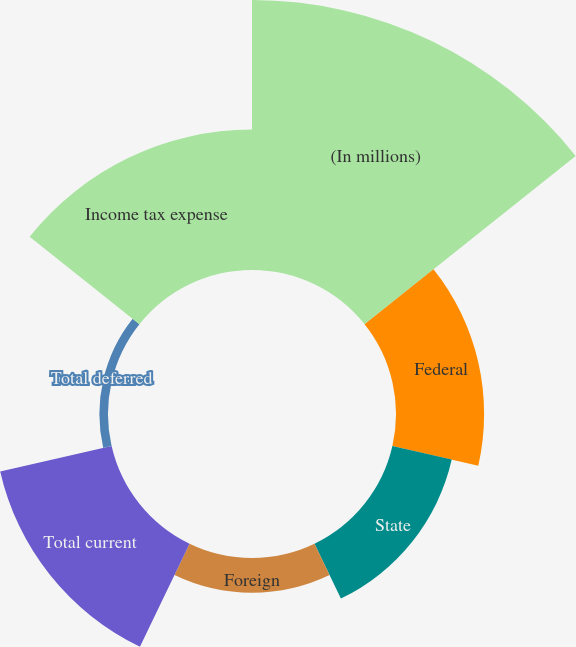<chart> <loc_0><loc_0><loc_500><loc_500><pie_chart><fcel>(In millions)<fcel>Federal<fcel>State<fcel>Foreign<fcel>Total current<fcel>Total deferred<fcel>Income tax expense<nl><fcel>37.66%<fcel>12.29%<fcel>8.49%<fcel>4.84%<fcel>15.94%<fcel>1.2%<fcel>19.58%<nl></chart> 